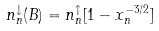<formula> <loc_0><loc_0><loc_500><loc_500>n _ { n } ^ { \downarrow } ( B ) = n _ { n } ^ { \uparrow } [ 1 - x _ { n } ^ { - 3 / 2 } ]</formula> 